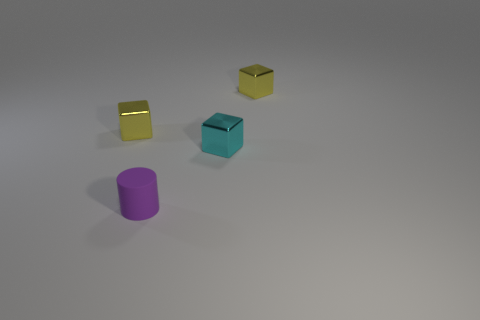There is a shiny cube left of the small cylinder; what color is it? The cube located to the left of the small cylinder has a glossy surface and appears to be gold in color, reflecting light on its surface creating a shiny effect. 